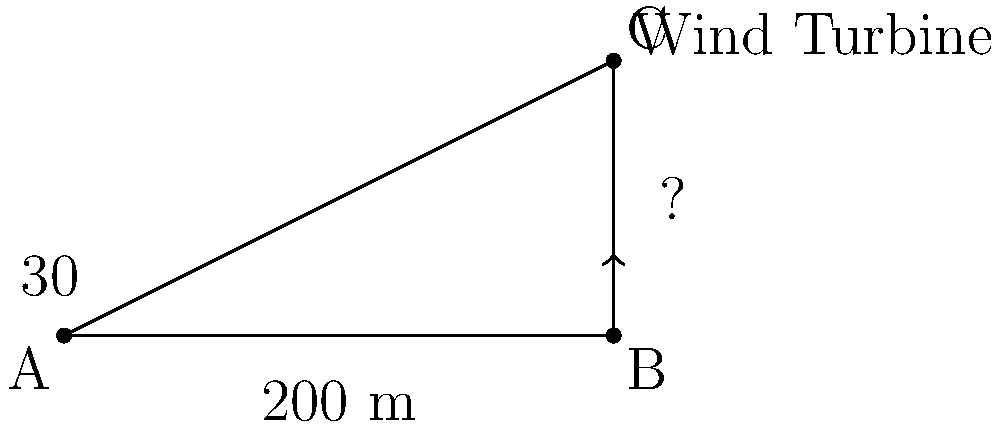As part of an eco-friendly energy initiative, you're assessing the potential for wind energy in your area. From a distance of 200 meters from the base of a wind turbine, you measure the angle of elevation to the top of the turbine to be 30°. Calculate the height of the wind turbine to determine its suitability for the local landscape and potential energy output. Let's approach this step-by-step:

1) We can use the tangent function to solve this problem. The tangent of an angle in a right triangle is the ratio of the opposite side to the adjacent side.

2) In this case:
   - The angle of elevation is 30°
   - The adjacent side is the distance from the observer to the base of the turbine (200 m)
   - The opposite side is the height of the turbine, which we need to find

3) Let's call the height of the turbine $h$. We can write the equation:

   $$\tan(30°) = \frac{h}{200}$$

4) We know that $\tan(30°) = \frac{1}{\sqrt{3}}$. Substituting this:

   $$\frac{1}{\sqrt{3}} = \frac{h}{200}$$

5) To solve for $h$, multiply both sides by 200:

   $$\frac{200}{\sqrt{3}} = h$$

6) Simplify:
   
   $$h = 200 \cdot \frac{1}{\sqrt{3}} \approx 115.47 \text{ meters}$$

7) Rounding to the nearest meter:

   $$h \approx 115 \text{ meters}$$

This height is suitable for a modern wind turbine and could potentially generate a significant amount of clean energy, contributing to sustainable development goals.
Answer: 115 meters 